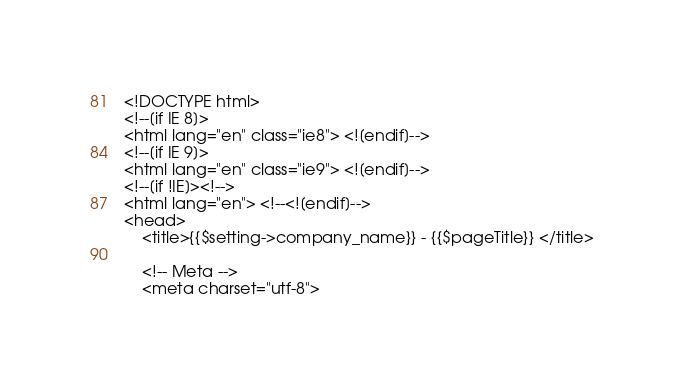Convert code to text. <code><loc_0><loc_0><loc_500><loc_500><_PHP_><!DOCTYPE html>
<!--[if IE 8]>
<html lang="en" class="ie8"> <![endif]-->
<!--[if IE 9]>
<html lang="en" class="ie9"> <![endif]-->
<!--[if !IE]><!-->
<html lang="en"> <!--<![endif]-->
<head>
    <title>{{$setting->company_name}} - {{$pageTitle}} </title>

    <!-- Meta -->
    <meta charset="utf-8"></code> 